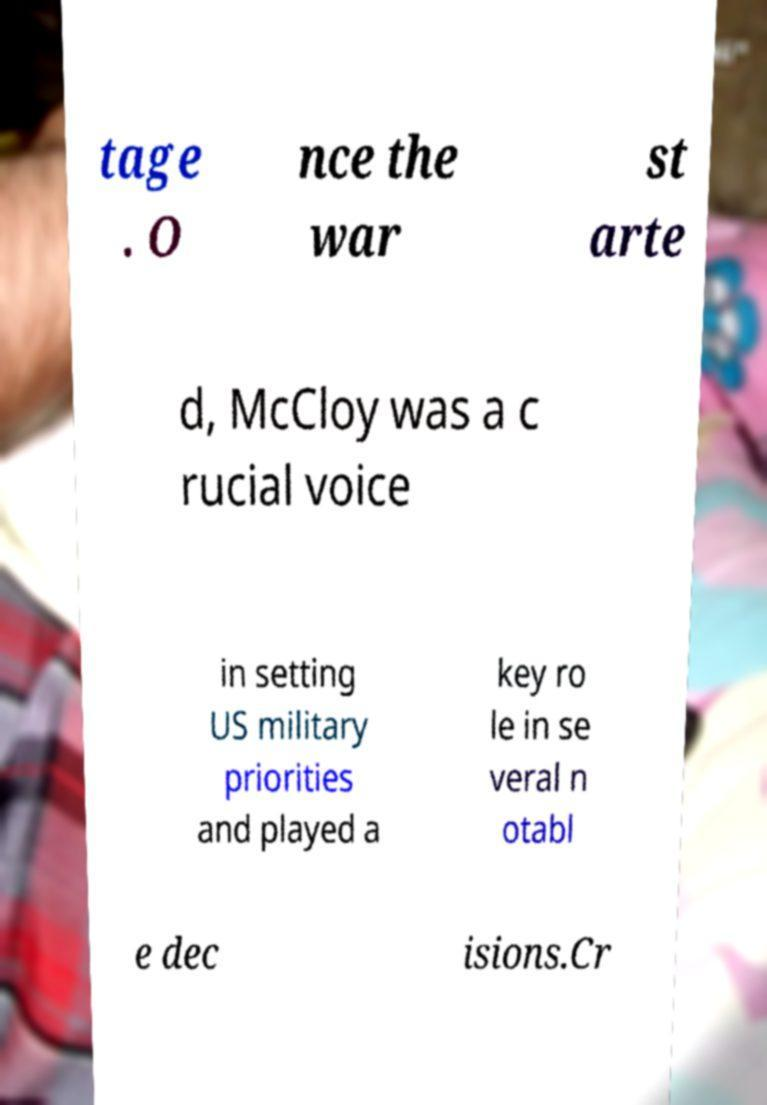Could you extract and type out the text from this image? tage . O nce the war st arte d, McCloy was a c rucial voice in setting US military priorities and played a key ro le in se veral n otabl e dec isions.Cr 